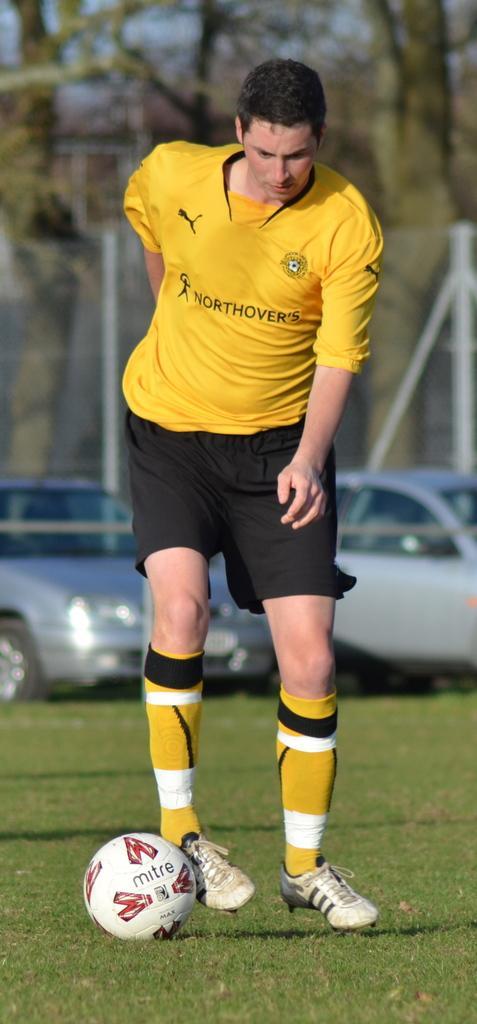Describe this image in one or two sentences. This picture shows a man playing football and we see few cars parked and trees 